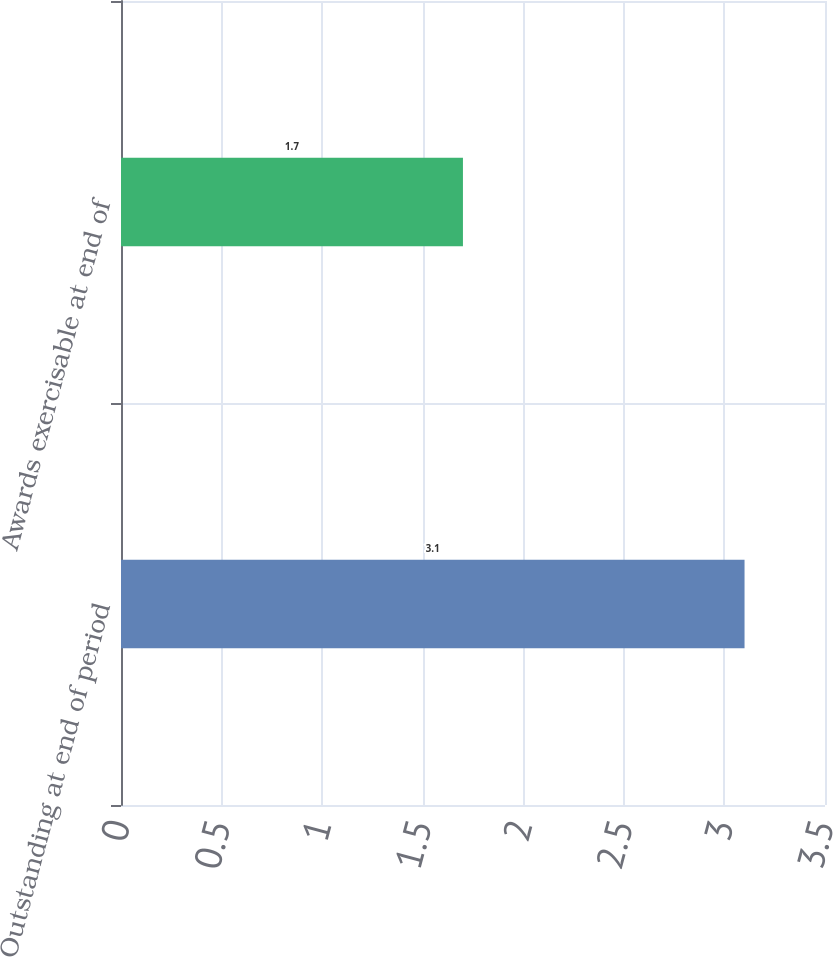Convert chart. <chart><loc_0><loc_0><loc_500><loc_500><bar_chart><fcel>Outstanding at end of period<fcel>Awards exercisable at end of<nl><fcel>3.1<fcel>1.7<nl></chart> 